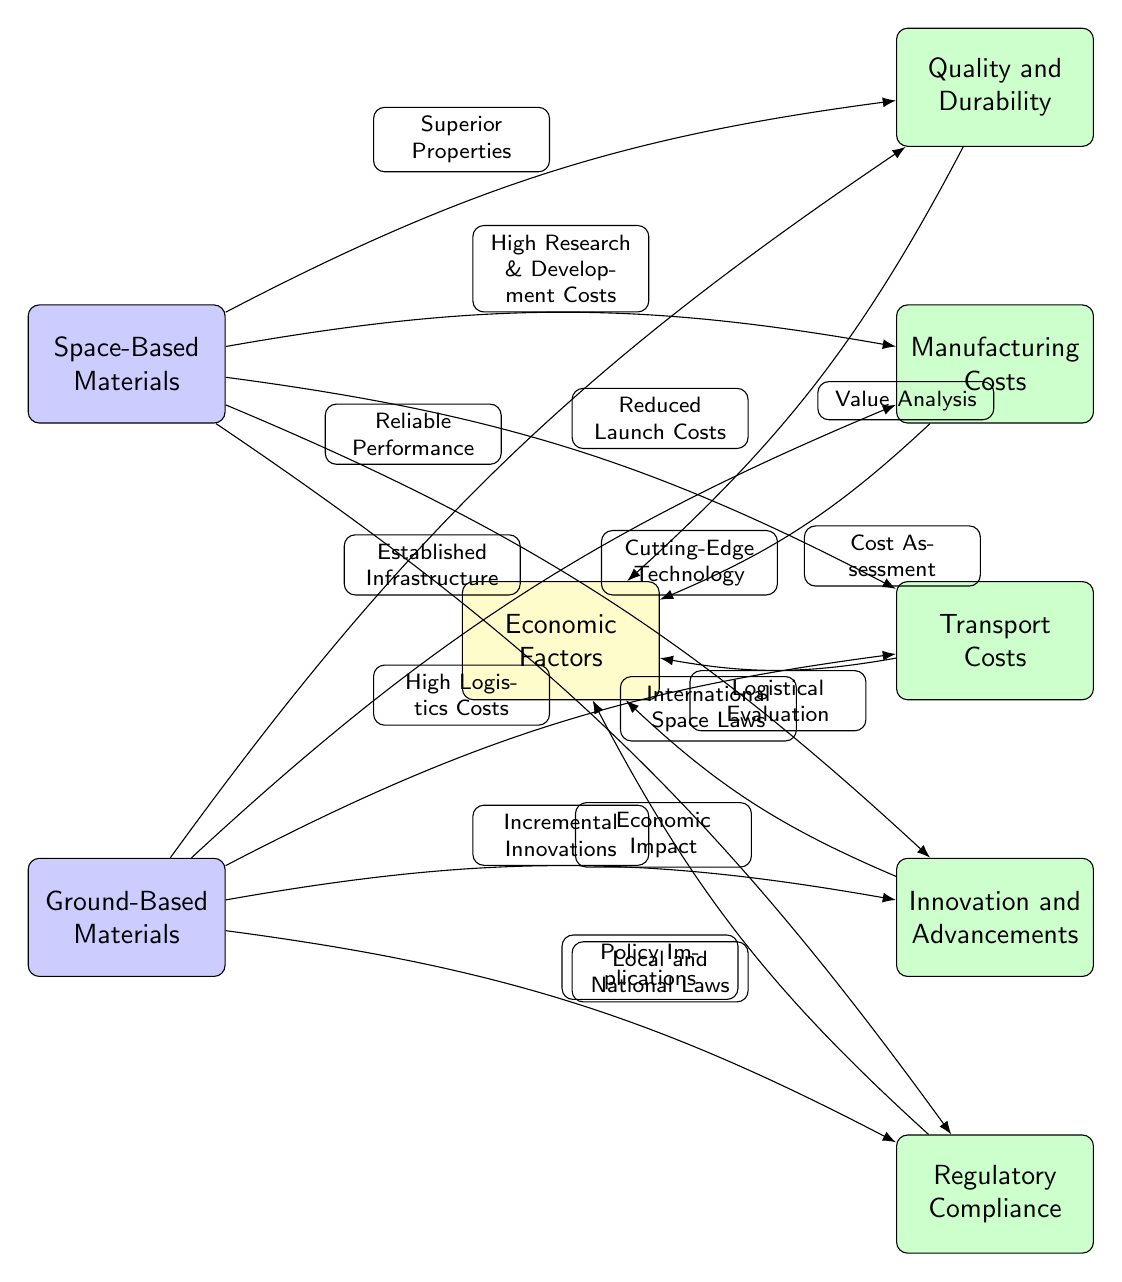What are the two types of materials mentioned in the diagram? The diagram includes two nodes for materials: "Space-Based Materials" and "Ground-Based Materials" located at the left side.
Answer: Space-Based Materials, Ground-Based Materials How many tertiary factors are connected to Economic Factors? The economic factors have four tertiary nodes connected to it: "Manufacturing Costs," "Transport Costs," "Innovation and Advancements," and "Quality and Durability." The count is determined by observing the connections.
Answer: 4 What does "Innovation and Advancements" connect to? "Innovation and Advancements" is connected to the "Economic Impact" edge, which leads to the "Economic Factors" node. This connection indicates its effect on economics.
Answer: Economic Impact Which type of materials is associated with high research and development costs? The node "High Research & Development Costs" connects to "Space-Based Materials," indicating that it is linked to the costs involved in developing these materials.
Answer: Space-Based Materials What node indicates high logistics costs? The edge "High Logistics Costs" directly connects to the node "Ground-Based Materials," highlighting the associated costs for logistical operations.
Answer: Ground-Based Materials What is the relationship between "Quality and Durability" and "Manufacturing Costs"? "Quality and Durability" connects to "Cost Assessment," which is an edge leading from "Manufacturing Costs," indicating that quality affects the assessment of manufacturing costs.
Answer: Cost Assessment What regulatory aspect is connected to "Space-Based Materials"? The connection labeled "International Space Laws" ties into the "Regulatory Compliance" node from "Space-Based Materials". This indicates it pertains to regulations governing space-based activities.
Answer: International Space Laws How does "Ground-Based Materials" relate to "Quality and Durability"? "Ground-Based Materials" is connected to "Reliable Performance," which influences "Quality and Durability," showing that these materials offer dependable characteristics.
Answer: Reliable Performance What are the factors influencing transport costs related to space-based materials? The node "Reduced Launch Costs" from "Space-Based Materials" connects to "Transport Costs," indicating a beneficial economic factor in transportation logistics.
Answer: Reduced Launch Costs 